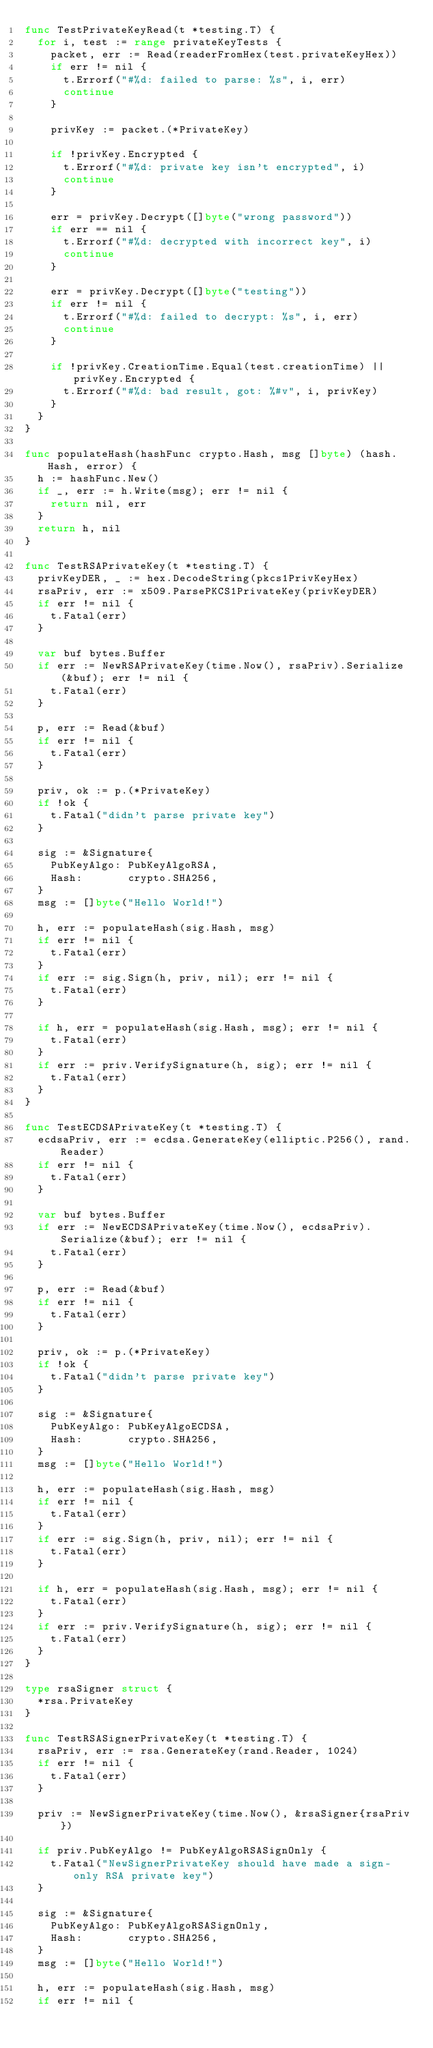<code> <loc_0><loc_0><loc_500><loc_500><_Go_>func TestPrivateKeyRead(t *testing.T) {
	for i, test := range privateKeyTests {
		packet, err := Read(readerFromHex(test.privateKeyHex))
		if err != nil {
			t.Errorf("#%d: failed to parse: %s", i, err)
			continue
		}

		privKey := packet.(*PrivateKey)

		if !privKey.Encrypted {
			t.Errorf("#%d: private key isn't encrypted", i)
			continue
		}

		err = privKey.Decrypt([]byte("wrong password"))
		if err == nil {
			t.Errorf("#%d: decrypted with incorrect key", i)
			continue
		}

		err = privKey.Decrypt([]byte("testing"))
		if err != nil {
			t.Errorf("#%d: failed to decrypt: %s", i, err)
			continue
		}

		if !privKey.CreationTime.Equal(test.creationTime) || privKey.Encrypted {
			t.Errorf("#%d: bad result, got: %#v", i, privKey)
		}
	}
}

func populateHash(hashFunc crypto.Hash, msg []byte) (hash.Hash, error) {
	h := hashFunc.New()
	if _, err := h.Write(msg); err != nil {
		return nil, err
	}
	return h, nil
}

func TestRSAPrivateKey(t *testing.T) {
	privKeyDER, _ := hex.DecodeString(pkcs1PrivKeyHex)
	rsaPriv, err := x509.ParsePKCS1PrivateKey(privKeyDER)
	if err != nil {
		t.Fatal(err)
	}

	var buf bytes.Buffer
	if err := NewRSAPrivateKey(time.Now(), rsaPriv).Serialize(&buf); err != nil {
		t.Fatal(err)
	}

	p, err := Read(&buf)
	if err != nil {
		t.Fatal(err)
	}

	priv, ok := p.(*PrivateKey)
	if !ok {
		t.Fatal("didn't parse private key")
	}

	sig := &Signature{
		PubKeyAlgo: PubKeyAlgoRSA,
		Hash:       crypto.SHA256,
	}
	msg := []byte("Hello World!")

	h, err := populateHash(sig.Hash, msg)
	if err != nil {
		t.Fatal(err)
	}
	if err := sig.Sign(h, priv, nil); err != nil {
		t.Fatal(err)
	}

	if h, err = populateHash(sig.Hash, msg); err != nil {
		t.Fatal(err)
	}
	if err := priv.VerifySignature(h, sig); err != nil {
		t.Fatal(err)
	}
}

func TestECDSAPrivateKey(t *testing.T) {
	ecdsaPriv, err := ecdsa.GenerateKey(elliptic.P256(), rand.Reader)
	if err != nil {
		t.Fatal(err)
	}

	var buf bytes.Buffer
	if err := NewECDSAPrivateKey(time.Now(), ecdsaPriv).Serialize(&buf); err != nil {
		t.Fatal(err)
	}

	p, err := Read(&buf)
	if err != nil {
		t.Fatal(err)
	}

	priv, ok := p.(*PrivateKey)
	if !ok {
		t.Fatal("didn't parse private key")
	}

	sig := &Signature{
		PubKeyAlgo: PubKeyAlgoECDSA,
		Hash:       crypto.SHA256,
	}
	msg := []byte("Hello World!")

	h, err := populateHash(sig.Hash, msg)
	if err != nil {
		t.Fatal(err)
	}
	if err := sig.Sign(h, priv, nil); err != nil {
		t.Fatal(err)
	}

	if h, err = populateHash(sig.Hash, msg); err != nil {
		t.Fatal(err)
	}
	if err := priv.VerifySignature(h, sig); err != nil {
		t.Fatal(err)
	}
}

type rsaSigner struct {
	*rsa.PrivateKey
}

func TestRSASignerPrivateKey(t *testing.T) {
	rsaPriv, err := rsa.GenerateKey(rand.Reader, 1024)
	if err != nil {
		t.Fatal(err)
	}

	priv := NewSignerPrivateKey(time.Now(), &rsaSigner{rsaPriv})

	if priv.PubKeyAlgo != PubKeyAlgoRSASignOnly {
		t.Fatal("NewSignerPrivateKey should have made a sign-only RSA private key")
	}

	sig := &Signature{
		PubKeyAlgo: PubKeyAlgoRSASignOnly,
		Hash:       crypto.SHA256,
	}
	msg := []byte("Hello World!")

	h, err := populateHash(sig.Hash, msg)
	if err != nil {</code> 